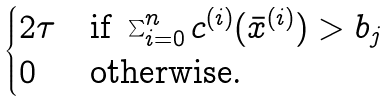<formula> <loc_0><loc_0><loc_500><loc_500>\begin{cases} 2 \tau & \text {if } \sum _ { i = 0 } ^ { n } c ^ { ( i ) } ( \bar { x } ^ { ( i ) } ) > b _ { j } \\ 0 & \text {otherwise.} \end{cases}</formula> 